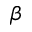<formula> <loc_0><loc_0><loc_500><loc_500>\beta</formula> 